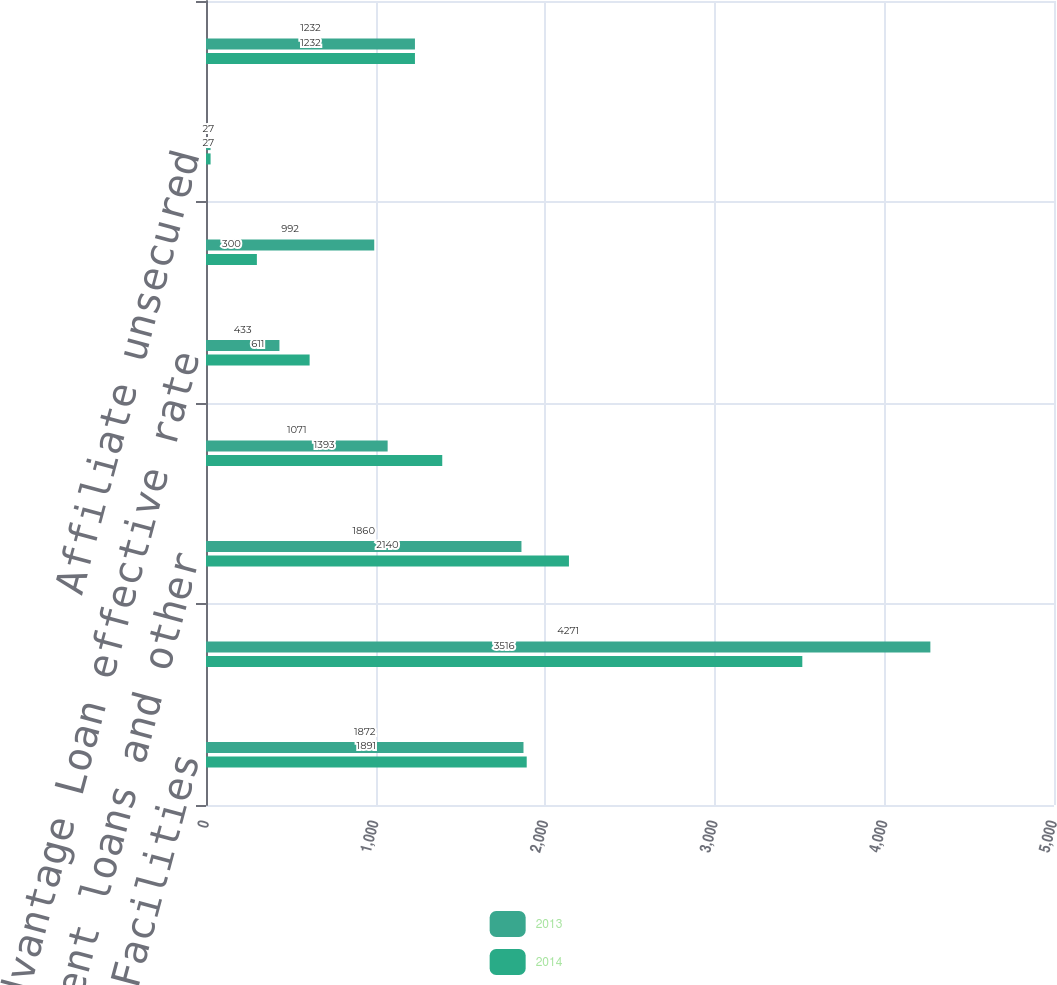<chart> <loc_0><loc_0><loc_500><loc_500><stacked_bar_chart><ecel><fcel>2013 Credit Facilities<fcel>Aircraft enhanced equipment<fcel>Equipment loans and other<fcel>Special facility revenue bonds<fcel>AAdvantage Loan effective rate<fcel>Other secured obligations<fcel>Affiliate unsecured<fcel>Total long-term debt and<nl><fcel>2013<fcel>1872<fcel>4271<fcel>1860<fcel>1071<fcel>433<fcel>992<fcel>27<fcel>1232<nl><fcel>2014<fcel>1891<fcel>3516<fcel>2140<fcel>1393<fcel>611<fcel>300<fcel>27<fcel>1232<nl></chart> 